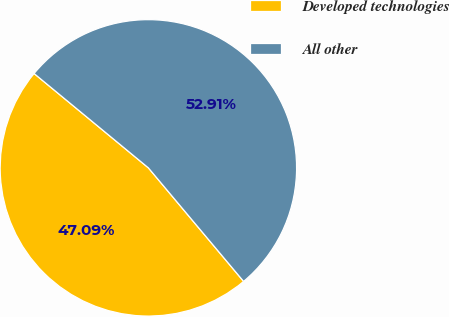Convert chart to OTSL. <chart><loc_0><loc_0><loc_500><loc_500><pie_chart><fcel>Developed technologies<fcel>All other<nl><fcel>47.09%<fcel>52.91%<nl></chart> 